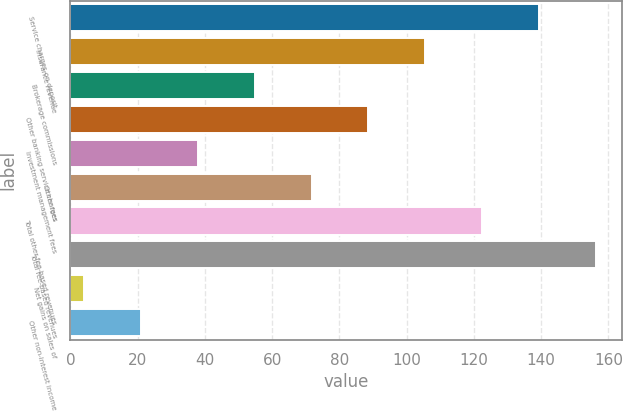Convert chart to OTSL. <chart><loc_0><loc_0><loc_500><loc_500><bar_chart><fcel>Service charges on deposit<fcel>Insurance revenue<fcel>Brokerage commissions<fcel>Other banking service charges<fcel>Investment management fees<fcel>Other fees<fcel>Total other fee-based revenues<fcel>Total fee-based revenues<fcel>Net gains on sales of<fcel>Other non-interest income<nl><fcel>139.44<fcel>105.58<fcel>54.79<fcel>88.65<fcel>37.86<fcel>71.72<fcel>122.51<fcel>156.37<fcel>4<fcel>20.93<nl></chart> 